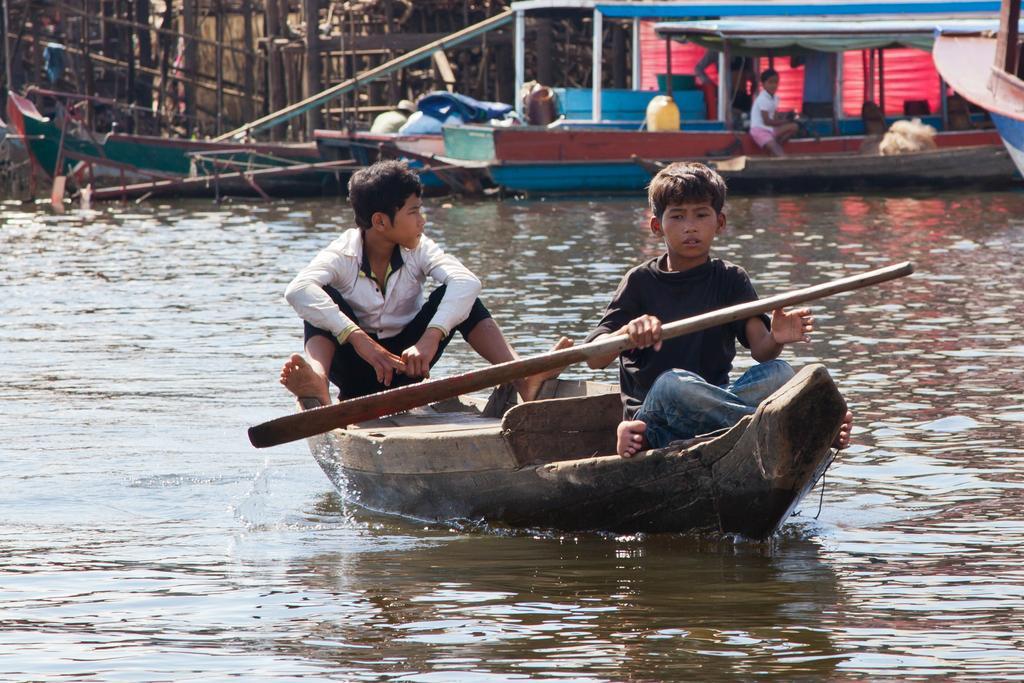In one or two sentences, can you explain what this image depicts? In this image in the front there is water and in the center there is a boat and on the boat there are persons sitting and rowing a boat. In the background there are boats on the water and there are objects which looks like wood and there are persons on the boat and there is an object which is red in colour. 